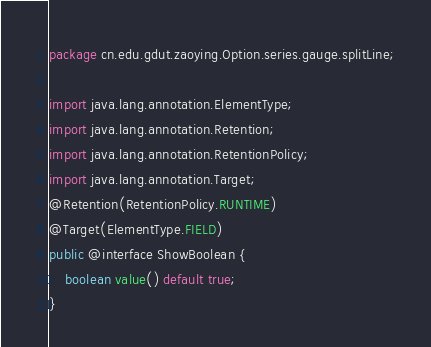<code> <loc_0><loc_0><loc_500><loc_500><_Java_>package cn.edu.gdut.zaoying.Option.series.gauge.splitLine;

import java.lang.annotation.ElementType;
import java.lang.annotation.Retention;
import java.lang.annotation.RetentionPolicy;
import java.lang.annotation.Target;
@Retention(RetentionPolicy.RUNTIME)
@Target(ElementType.FIELD)
public @interface ShowBoolean {
    boolean value() default true;
}</code> 